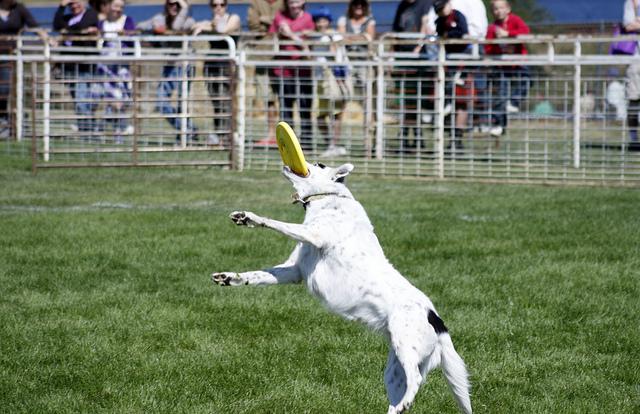Is this an adult dog?
Quick response, please. Yes. Does the dog have all 4 paws on the ground?
Give a very brief answer. No. Is the dog trying to eat the frisbee?
Keep it brief. No. 